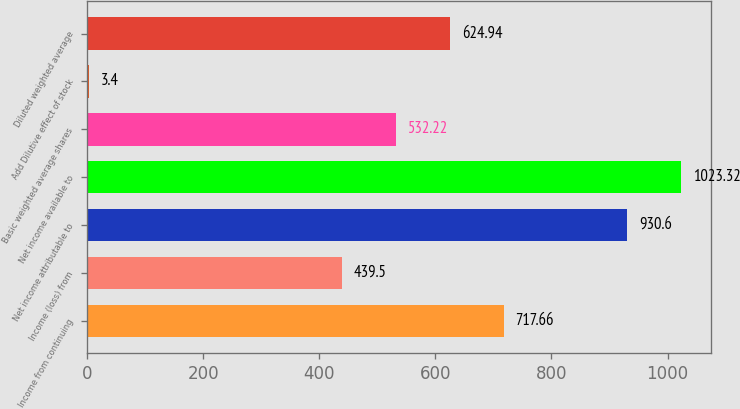<chart> <loc_0><loc_0><loc_500><loc_500><bar_chart><fcel>Income from continuing<fcel>Income (loss) from<fcel>Net income attributable to<fcel>Net income available to<fcel>Basic weighted average shares<fcel>Add Dilutive effect of stock<fcel>Diluted weighted average<nl><fcel>717.66<fcel>439.5<fcel>930.6<fcel>1023.32<fcel>532.22<fcel>3.4<fcel>624.94<nl></chart> 